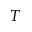Convert formula to latex. <formula><loc_0><loc_0><loc_500><loc_500>T</formula> 